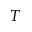Convert formula to latex. <formula><loc_0><loc_0><loc_500><loc_500>T</formula> 